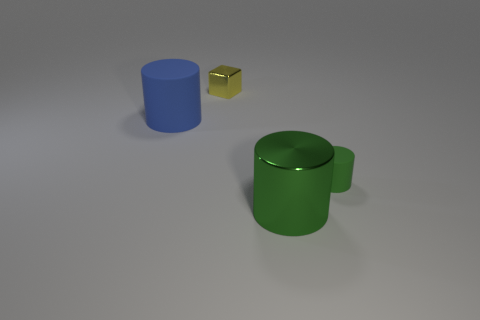Are there any other things that are the same color as the tiny metallic thing?
Provide a short and direct response. No. Is the green matte thing the same shape as the small yellow object?
Make the answer very short. No. There is a matte cylinder to the right of the metal thing that is behind the big object that is in front of the big blue cylinder; what size is it?
Offer a terse response. Small. What is the color of the matte object that is to the left of the large green metal cylinder?
Provide a short and direct response. Blue. There is a small object that is in front of the object that is left of the tiny object that is on the left side of the large shiny cylinder; what is its material?
Provide a short and direct response. Rubber. Is there another big metallic object of the same shape as the blue thing?
Your answer should be compact. Yes. There is a yellow object that is the same size as the green matte thing; what shape is it?
Ensure brevity in your answer.  Cube. What number of cylinders are left of the tiny green object and on the right side of the yellow object?
Offer a terse response. 1. Are there fewer big green objects behind the block than small purple metallic spheres?
Provide a succinct answer. No. Is there a green cylinder that has the same size as the yellow metal block?
Make the answer very short. Yes. 